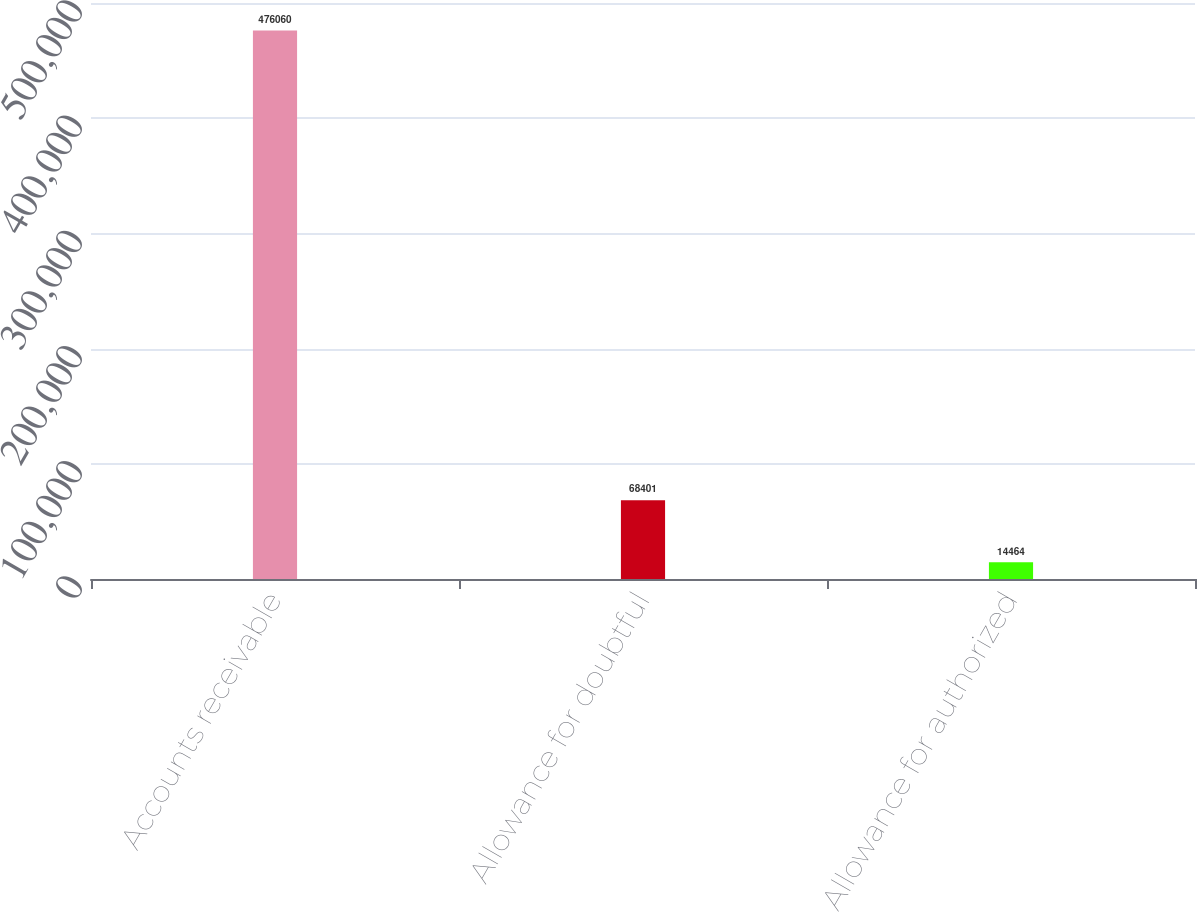Convert chart to OTSL. <chart><loc_0><loc_0><loc_500><loc_500><bar_chart><fcel>Accounts receivable<fcel>Allowance for doubtful<fcel>Allowance for authorized<nl><fcel>476060<fcel>68401<fcel>14464<nl></chart> 